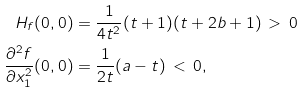<formula> <loc_0><loc_0><loc_500><loc_500>H _ { f } ( 0 , 0 ) & = \frac { 1 } { 4 t ^ { 2 } } ( t + 1 ) ( t + 2 b + 1 ) \, > \, 0 \\ \frac { \partial ^ { 2 } f } { \partial x _ { 1 } ^ { 2 } } ( 0 , 0 ) & = \frac { 1 } { 2 t } ( a - t ) \, < \, 0 ,</formula> 